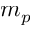Convert formula to latex. <formula><loc_0><loc_0><loc_500><loc_500>m _ { p }</formula> 